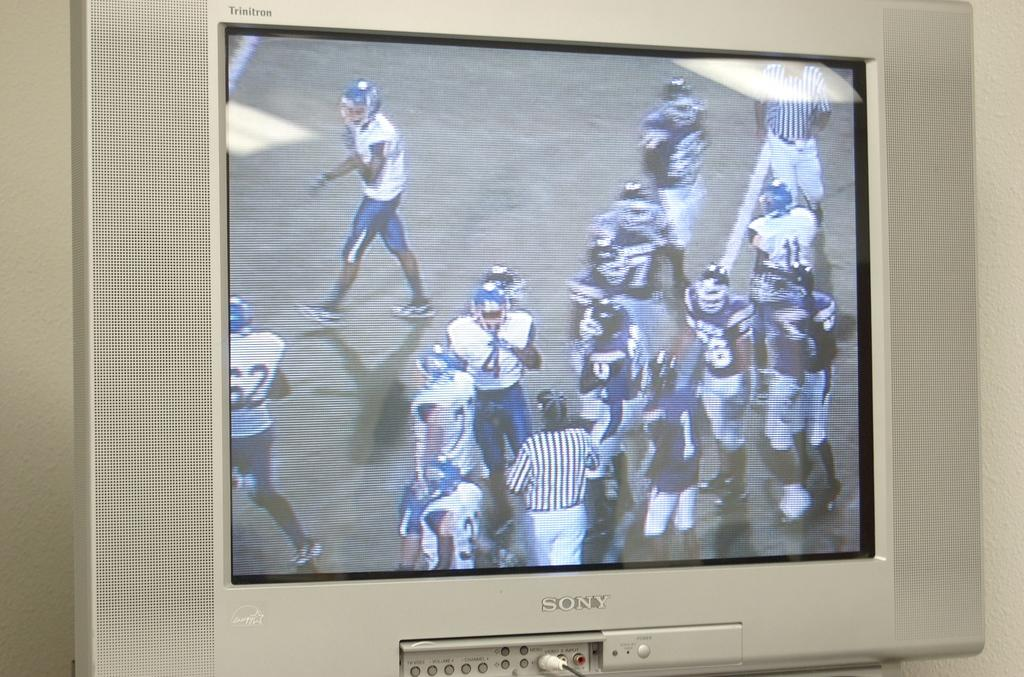<image>
Offer a succinct explanation of the picture presented. A flat screen Sony TV showing a group of football players from opposing teams standing around. 